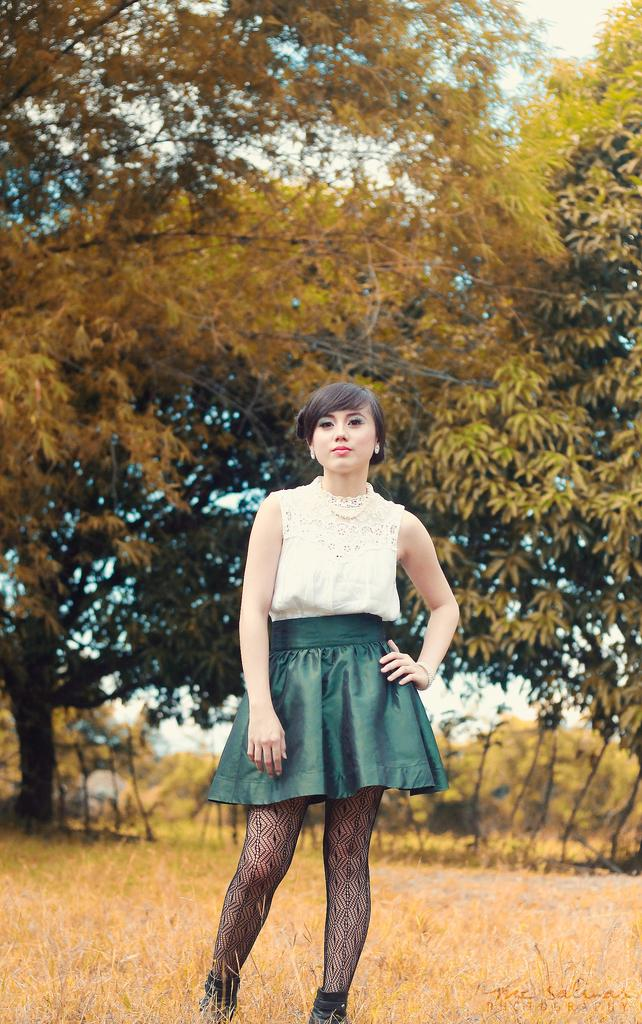Who is present in the image? There is a woman in the image. What is the woman wearing? The woman is wearing a green and white dress. What is the woman's position in the image? The woman is standing on the ground. What type of vegetation can be seen in the image? There are trees, bushes, and plants in the image. What is the ground covered with? The ground is covered with grass. What is visible at the top of the image? The sky is visible at the top of the image. What type of badge is the woman wearing in the image? There is no badge visible on the woman in the image. What activity is the woman participating in during recess? The image does not depict a recess or any specific activity. 